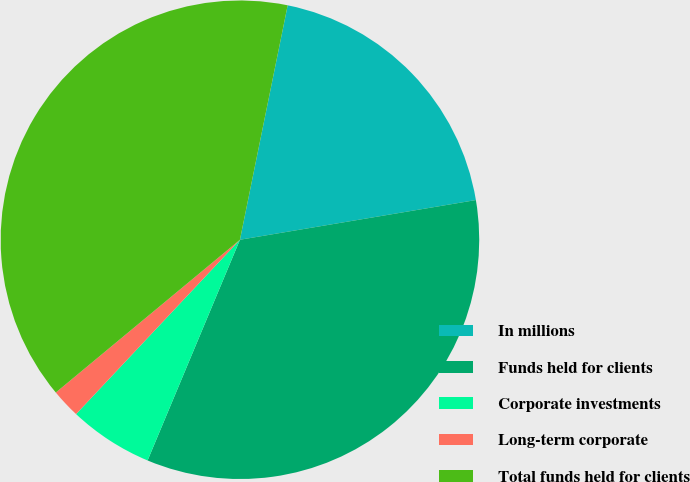Convert chart. <chart><loc_0><loc_0><loc_500><loc_500><pie_chart><fcel>In millions<fcel>Funds held for clients<fcel>Corporate investments<fcel>Long-term corporate<fcel>Total funds held for clients<nl><fcel>19.15%<fcel>33.96%<fcel>5.7%<fcel>1.97%<fcel>39.22%<nl></chart> 